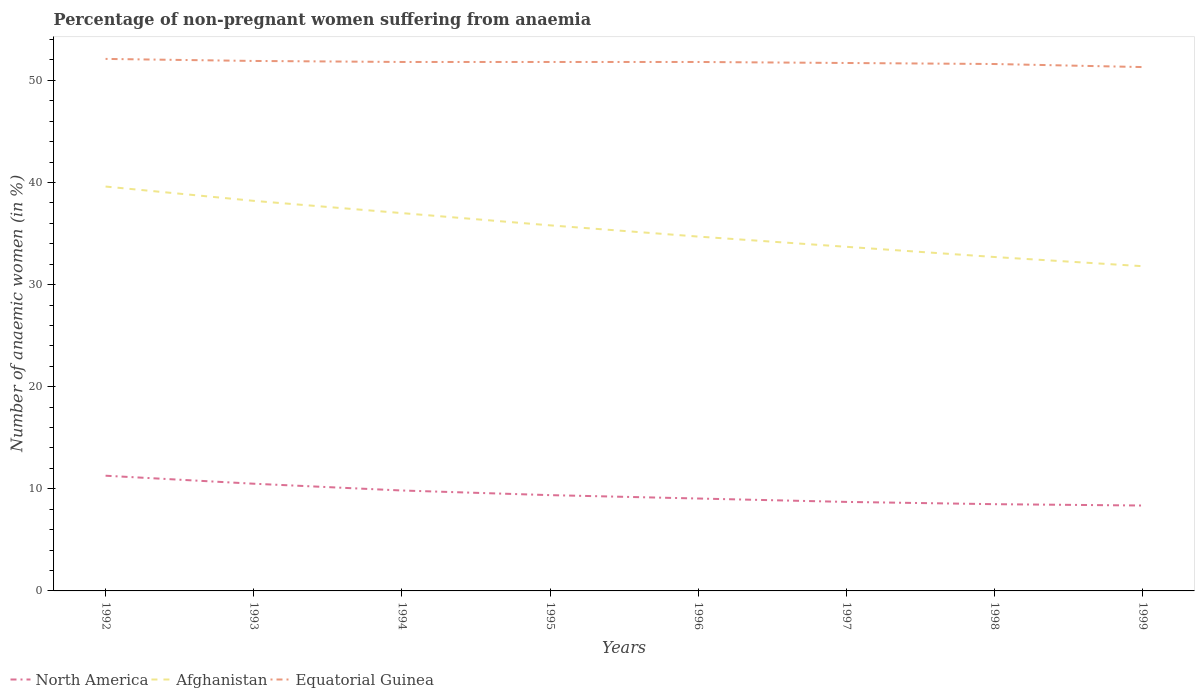Across all years, what is the maximum percentage of non-pregnant women suffering from anaemia in North America?
Give a very brief answer. 8.36. In which year was the percentage of non-pregnant women suffering from anaemia in North America maximum?
Give a very brief answer. 1999. What is the difference between the highest and the second highest percentage of non-pregnant women suffering from anaemia in North America?
Your answer should be very brief. 2.92. Is the percentage of non-pregnant women suffering from anaemia in North America strictly greater than the percentage of non-pregnant women suffering from anaemia in Afghanistan over the years?
Give a very brief answer. Yes. How many years are there in the graph?
Give a very brief answer. 8. Are the values on the major ticks of Y-axis written in scientific E-notation?
Keep it short and to the point. No. Does the graph contain any zero values?
Your answer should be very brief. No. Does the graph contain grids?
Your answer should be compact. No. How many legend labels are there?
Make the answer very short. 3. How are the legend labels stacked?
Ensure brevity in your answer.  Horizontal. What is the title of the graph?
Your answer should be compact. Percentage of non-pregnant women suffering from anaemia. What is the label or title of the X-axis?
Keep it short and to the point. Years. What is the label or title of the Y-axis?
Offer a very short reply. Number of anaemic women (in %). What is the Number of anaemic women (in %) in North America in 1992?
Provide a succinct answer. 11.28. What is the Number of anaemic women (in %) of Afghanistan in 1992?
Keep it short and to the point. 39.6. What is the Number of anaemic women (in %) in Equatorial Guinea in 1992?
Provide a short and direct response. 52.1. What is the Number of anaemic women (in %) of North America in 1993?
Your answer should be very brief. 10.5. What is the Number of anaemic women (in %) in Afghanistan in 1993?
Provide a succinct answer. 38.2. What is the Number of anaemic women (in %) in Equatorial Guinea in 1993?
Provide a succinct answer. 51.9. What is the Number of anaemic women (in %) in North America in 1994?
Offer a very short reply. 9.83. What is the Number of anaemic women (in %) in Equatorial Guinea in 1994?
Your response must be concise. 51.8. What is the Number of anaemic women (in %) in North America in 1995?
Offer a terse response. 9.38. What is the Number of anaemic women (in %) of Afghanistan in 1995?
Offer a very short reply. 35.8. What is the Number of anaemic women (in %) of Equatorial Guinea in 1995?
Offer a terse response. 51.8. What is the Number of anaemic women (in %) of North America in 1996?
Ensure brevity in your answer.  9.05. What is the Number of anaemic women (in %) of Afghanistan in 1996?
Offer a very short reply. 34.7. What is the Number of anaemic women (in %) in Equatorial Guinea in 1996?
Provide a succinct answer. 51.8. What is the Number of anaemic women (in %) in North America in 1997?
Your answer should be very brief. 8.72. What is the Number of anaemic women (in %) in Afghanistan in 1997?
Your answer should be compact. 33.7. What is the Number of anaemic women (in %) of Equatorial Guinea in 1997?
Your response must be concise. 51.7. What is the Number of anaemic women (in %) in North America in 1998?
Your answer should be compact. 8.49. What is the Number of anaemic women (in %) of Afghanistan in 1998?
Your response must be concise. 32.7. What is the Number of anaemic women (in %) of Equatorial Guinea in 1998?
Your answer should be very brief. 51.6. What is the Number of anaemic women (in %) of North America in 1999?
Provide a succinct answer. 8.36. What is the Number of anaemic women (in %) of Afghanistan in 1999?
Ensure brevity in your answer.  31.8. What is the Number of anaemic women (in %) in Equatorial Guinea in 1999?
Offer a terse response. 51.3. Across all years, what is the maximum Number of anaemic women (in %) of North America?
Provide a succinct answer. 11.28. Across all years, what is the maximum Number of anaemic women (in %) in Afghanistan?
Provide a succinct answer. 39.6. Across all years, what is the maximum Number of anaemic women (in %) in Equatorial Guinea?
Provide a succinct answer. 52.1. Across all years, what is the minimum Number of anaemic women (in %) in North America?
Provide a short and direct response. 8.36. Across all years, what is the minimum Number of anaemic women (in %) in Afghanistan?
Ensure brevity in your answer.  31.8. Across all years, what is the minimum Number of anaemic women (in %) of Equatorial Guinea?
Keep it short and to the point. 51.3. What is the total Number of anaemic women (in %) of North America in the graph?
Give a very brief answer. 75.62. What is the total Number of anaemic women (in %) in Afghanistan in the graph?
Offer a very short reply. 283.5. What is the total Number of anaemic women (in %) of Equatorial Guinea in the graph?
Make the answer very short. 414. What is the difference between the Number of anaemic women (in %) in North America in 1992 and that in 1993?
Your answer should be compact. 0.78. What is the difference between the Number of anaemic women (in %) in Afghanistan in 1992 and that in 1993?
Provide a short and direct response. 1.4. What is the difference between the Number of anaemic women (in %) in North America in 1992 and that in 1994?
Ensure brevity in your answer.  1.45. What is the difference between the Number of anaemic women (in %) in Afghanistan in 1992 and that in 1994?
Provide a succinct answer. 2.6. What is the difference between the Number of anaemic women (in %) of Equatorial Guinea in 1992 and that in 1994?
Your answer should be compact. 0.3. What is the difference between the Number of anaemic women (in %) of North America in 1992 and that in 1995?
Ensure brevity in your answer.  1.9. What is the difference between the Number of anaemic women (in %) in Afghanistan in 1992 and that in 1995?
Give a very brief answer. 3.8. What is the difference between the Number of anaemic women (in %) of North America in 1992 and that in 1996?
Your answer should be compact. 2.23. What is the difference between the Number of anaemic women (in %) of Afghanistan in 1992 and that in 1996?
Offer a very short reply. 4.9. What is the difference between the Number of anaemic women (in %) of Equatorial Guinea in 1992 and that in 1996?
Keep it short and to the point. 0.3. What is the difference between the Number of anaemic women (in %) in North America in 1992 and that in 1997?
Give a very brief answer. 2.57. What is the difference between the Number of anaemic women (in %) in Afghanistan in 1992 and that in 1997?
Your response must be concise. 5.9. What is the difference between the Number of anaemic women (in %) of Equatorial Guinea in 1992 and that in 1997?
Your response must be concise. 0.4. What is the difference between the Number of anaemic women (in %) of North America in 1992 and that in 1998?
Offer a very short reply. 2.79. What is the difference between the Number of anaemic women (in %) of Afghanistan in 1992 and that in 1998?
Offer a terse response. 6.9. What is the difference between the Number of anaemic women (in %) of Equatorial Guinea in 1992 and that in 1998?
Keep it short and to the point. 0.5. What is the difference between the Number of anaemic women (in %) in North America in 1992 and that in 1999?
Provide a succinct answer. 2.92. What is the difference between the Number of anaemic women (in %) in North America in 1993 and that in 1994?
Your answer should be compact. 0.66. What is the difference between the Number of anaemic women (in %) in Equatorial Guinea in 1993 and that in 1994?
Offer a terse response. 0.1. What is the difference between the Number of anaemic women (in %) in North America in 1993 and that in 1995?
Keep it short and to the point. 1.12. What is the difference between the Number of anaemic women (in %) in Afghanistan in 1993 and that in 1995?
Keep it short and to the point. 2.4. What is the difference between the Number of anaemic women (in %) of Equatorial Guinea in 1993 and that in 1995?
Give a very brief answer. 0.1. What is the difference between the Number of anaemic women (in %) of North America in 1993 and that in 1996?
Your answer should be compact. 1.45. What is the difference between the Number of anaemic women (in %) of Equatorial Guinea in 1993 and that in 1996?
Make the answer very short. 0.1. What is the difference between the Number of anaemic women (in %) of North America in 1993 and that in 1997?
Your response must be concise. 1.78. What is the difference between the Number of anaemic women (in %) of North America in 1993 and that in 1998?
Provide a succinct answer. 2. What is the difference between the Number of anaemic women (in %) in Afghanistan in 1993 and that in 1998?
Your answer should be very brief. 5.5. What is the difference between the Number of anaemic women (in %) of Equatorial Guinea in 1993 and that in 1998?
Give a very brief answer. 0.3. What is the difference between the Number of anaemic women (in %) in North America in 1993 and that in 1999?
Offer a terse response. 2.14. What is the difference between the Number of anaemic women (in %) of Afghanistan in 1993 and that in 1999?
Give a very brief answer. 6.4. What is the difference between the Number of anaemic women (in %) of Equatorial Guinea in 1993 and that in 1999?
Offer a very short reply. 0.6. What is the difference between the Number of anaemic women (in %) of North America in 1994 and that in 1995?
Your answer should be very brief. 0.45. What is the difference between the Number of anaemic women (in %) of North America in 1994 and that in 1996?
Give a very brief answer. 0.79. What is the difference between the Number of anaemic women (in %) in Afghanistan in 1994 and that in 1996?
Provide a succinct answer. 2.3. What is the difference between the Number of anaemic women (in %) in North America in 1994 and that in 1997?
Ensure brevity in your answer.  1.12. What is the difference between the Number of anaemic women (in %) in Afghanistan in 1994 and that in 1997?
Offer a very short reply. 3.3. What is the difference between the Number of anaemic women (in %) of North America in 1994 and that in 1998?
Provide a short and direct response. 1.34. What is the difference between the Number of anaemic women (in %) of North America in 1994 and that in 1999?
Your response must be concise. 1.47. What is the difference between the Number of anaemic women (in %) of North America in 1995 and that in 1996?
Make the answer very short. 0.33. What is the difference between the Number of anaemic women (in %) of Afghanistan in 1995 and that in 1996?
Offer a terse response. 1.1. What is the difference between the Number of anaemic women (in %) in Equatorial Guinea in 1995 and that in 1996?
Your response must be concise. 0. What is the difference between the Number of anaemic women (in %) of North America in 1995 and that in 1997?
Your answer should be compact. 0.66. What is the difference between the Number of anaemic women (in %) in Afghanistan in 1995 and that in 1997?
Give a very brief answer. 2.1. What is the difference between the Number of anaemic women (in %) in Equatorial Guinea in 1995 and that in 1997?
Offer a terse response. 0.1. What is the difference between the Number of anaemic women (in %) in North America in 1995 and that in 1998?
Offer a terse response. 0.89. What is the difference between the Number of anaemic women (in %) of North America in 1996 and that in 1997?
Make the answer very short. 0.33. What is the difference between the Number of anaemic women (in %) in Afghanistan in 1996 and that in 1997?
Give a very brief answer. 1. What is the difference between the Number of anaemic women (in %) of Equatorial Guinea in 1996 and that in 1997?
Ensure brevity in your answer.  0.1. What is the difference between the Number of anaemic women (in %) of North America in 1996 and that in 1998?
Keep it short and to the point. 0.55. What is the difference between the Number of anaemic women (in %) of Equatorial Guinea in 1996 and that in 1998?
Provide a succinct answer. 0.2. What is the difference between the Number of anaemic women (in %) of North America in 1996 and that in 1999?
Give a very brief answer. 0.69. What is the difference between the Number of anaemic women (in %) of Equatorial Guinea in 1996 and that in 1999?
Your response must be concise. 0.5. What is the difference between the Number of anaemic women (in %) in North America in 1997 and that in 1998?
Ensure brevity in your answer.  0.22. What is the difference between the Number of anaemic women (in %) in Afghanistan in 1997 and that in 1998?
Give a very brief answer. 1. What is the difference between the Number of anaemic women (in %) of North America in 1997 and that in 1999?
Offer a very short reply. 0.35. What is the difference between the Number of anaemic women (in %) in Equatorial Guinea in 1997 and that in 1999?
Make the answer very short. 0.4. What is the difference between the Number of anaemic women (in %) of North America in 1998 and that in 1999?
Offer a very short reply. 0.13. What is the difference between the Number of anaemic women (in %) in North America in 1992 and the Number of anaemic women (in %) in Afghanistan in 1993?
Your answer should be compact. -26.92. What is the difference between the Number of anaemic women (in %) in North America in 1992 and the Number of anaemic women (in %) in Equatorial Guinea in 1993?
Keep it short and to the point. -40.62. What is the difference between the Number of anaemic women (in %) in North America in 1992 and the Number of anaemic women (in %) in Afghanistan in 1994?
Offer a terse response. -25.72. What is the difference between the Number of anaemic women (in %) in North America in 1992 and the Number of anaemic women (in %) in Equatorial Guinea in 1994?
Make the answer very short. -40.52. What is the difference between the Number of anaemic women (in %) of North America in 1992 and the Number of anaemic women (in %) of Afghanistan in 1995?
Offer a very short reply. -24.52. What is the difference between the Number of anaemic women (in %) of North America in 1992 and the Number of anaemic women (in %) of Equatorial Guinea in 1995?
Give a very brief answer. -40.52. What is the difference between the Number of anaemic women (in %) of Afghanistan in 1992 and the Number of anaemic women (in %) of Equatorial Guinea in 1995?
Your response must be concise. -12.2. What is the difference between the Number of anaemic women (in %) of North America in 1992 and the Number of anaemic women (in %) of Afghanistan in 1996?
Your answer should be very brief. -23.42. What is the difference between the Number of anaemic women (in %) in North America in 1992 and the Number of anaemic women (in %) in Equatorial Guinea in 1996?
Keep it short and to the point. -40.52. What is the difference between the Number of anaemic women (in %) of North America in 1992 and the Number of anaemic women (in %) of Afghanistan in 1997?
Make the answer very short. -22.42. What is the difference between the Number of anaemic women (in %) in North America in 1992 and the Number of anaemic women (in %) in Equatorial Guinea in 1997?
Offer a very short reply. -40.42. What is the difference between the Number of anaemic women (in %) of North America in 1992 and the Number of anaemic women (in %) of Afghanistan in 1998?
Keep it short and to the point. -21.42. What is the difference between the Number of anaemic women (in %) in North America in 1992 and the Number of anaemic women (in %) in Equatorial Guinea in 1998?
Make the answer very short. -40.32. What is the difference between the Number of anaemic women (in %) of Afghanistan in 1992 and the Number of anaemic women (in %) of Equatorial Guinea in 1998?
Your answer should be compact. -12. What is the difference between the Number of anaemic women (in %) in North America in 1992 and the Number of anaemic women (in %) in Afghanistan in 1999?
Your answer should be compact. -20.52. What is the difference between the Number of anaemic women (in %) in North America in 1992 and the Number of anaemic women (in %) in Equatorial Guinea in 1999?
Offer a very short reply. -40.02. What is the difference between the Number of anaemic women (in %) of North America in 1993 and the Number of anaemic women (in %) of Afghanistan in 1994?
Keep it short and to the point. -26.5. What is the difference between the Number of anaemic women (in %) of North America in 1993 and the Number of anaemic women (in %) of Equatorial Guinea in 1994?
Provide a short and direct response. -41.3. What is the difference between the Number of anaemic women (in %) in Afghanistan in 1993 and the Number of anaemic women (in %) in Equatorial Guinea in 1994?
Ensure brevity in your answer.  -13.6. What is the difference between the Number of anaemic women (in %) in North America in 1993 and the Number of anaemic women (in %) in Afghanistan in 1995?
Your response must be concise. -25.3. What is the difference between the Number of anaemic women (in %) of North America in 1993 and the Number of anaemic women (in %) of Equatorial Guinea in 1995?
Give a very brief answer. -41.3. What is the difference between the Number of anaemic women (in %) of North America in 1993 and the Number of anaemic women (in %) of Afghanistan in 1996?
Your response must be concise. -24.2. What is the difference between the Number of anaemic women (in %) in North America in 1993 and the Number of anaemic women (in %) in Equatorial Guinea in 1996?
Your response must be concise. -41.3. What is the difference between the Number of anaemic women (in %) in Afghanistan in 1993 and the Number of anaemic women (in %) in Equatorial Guinea in 1996?
Give a very brief answer. -13.6. What is the difference between the Number of anaemic women (in %) of North America in 1993 and the Number of anaemic women (in %) of Afghanistan in 1997?
Your answer should be very brief. -23.2. What is the difference between the Number of anaemic women (in %) of North America in 1993 and the Number of anaemic women (in %) of Equatorial Guinea in 1997?
Provide a short and direct response. -41.2. What is the difference between the Number of anaemic women (in %) in North America in 1993 and the Number of anaemic women (in %) in Afghanistan in 1998?
Your response must be concise. -22.2. What is the difference between the Number of anaemic women (in %) of North America in 1993 and the Number of anaemic women (in %) of Equatorial Guinea in 1998?
Keep it short and to the point. -41.1. What is the difference between the Number of anaemic women (in %) in Afghanistan in 1993 and the Number of anaemic women (in %) in Equatorial Guinea in 1998?
Your answer should be compact. -13.4. What is the difference between the Number of anaemic women (in %) in North America in 1993 and the Number of anaemic women (in %) in Afghanistan in 1999?
Your answer should be compact. -21.3. What is the difference between the Number of anaemic women (in %) in North America in 1993 and the Number of anaemic women (in %) in Equatorial Guinea in 1999?
Give a very brief answer. -40.8. What is the difference between the Number of anaemic women (in %) in North America in 1994 and the Number of anaemic women (in %) in Afghanistan in 1995?
Give a very brief answer. -25.97. What is the difference between the Number of anaemic women (in %) in North America in 1994 and the Number of anaemic women (in %) in Equatorial Guinea in 1995?
Offer a terse response. -41.97. What is the difference between the Number of anaemic women (in %) of Afghanistan in 1994 and the Number of anaemic women (in %) of Equatorial Guinea in 1995?
Keep it short and to the point. -14.8. What is the difference between the Number of anaemic women (in %) of North America in 1994 and the Number of anaemic women (in %) of Afghanistan in 1996?
Ensure brevity in your answer.  -24.87. What is the difference between the Number of anaemic women (in %) in North America in 1994 and the Number of anaemic women (in %) in Equatorial Guinea in 1996?
Keep it short and to the point. -41.97. What is the difference between the Number of anaemic women (in %) of Afghanistan in 1994 and the Number of anaemic women (in %) of Equatorial Guinea in 1996?
Keep it short and to the point. -14.8. What is the difference between the Number of anaemic women (in %) of North America in 1994 and the Number of anaemic women (in %) of Afghanistan in 1997?
Ensure brevity in your answer.  -23.87. What is the difference between the Number of anaemic women (in %) in North America in 1994 and the Number of anaemic women (in %) in Equatorial Guinea in 1997?
Provide a short and direct response. -41.87. What is the difference between the Number of anaemic women (in %) of Afghanistan in 1994 and the Number of anaemic women (in %) of Equatorial Guinea in 1997?
Provide a short and direct response. -14.7. What is the difference between the Number of anaemic women (in %) in North America in 1994 and the Number of anaemic women (in %) in Afghanistan in 1998?
Ensure brevity in your answer.  -22.87. What is the difference between the Number of anaemic women (in %) of North America in 1994 and the Number of anaemic women (in %) of Equatorial Guinea in 1998?
Keep it short and to the point. -41.77. What is the difference between the Number of anaemic women (in %) in Afghanistan in 1994 and the Number of anaemic women (in %) in Equatorial Guinea in 1998?
Your answer should be compact. -14.6. What is the difference between the Number of anaemic women (in %) in North America in 1994 and the Number of anaemic women (in %) in Afghanistan in 1999?
Make the answer very short. -21.97. What is the difference between the Number of anaemic women (in %) in North America in 1994 and the Number of anaemic women (in %) in Equatorial Guinea in 1999?
Ensure brevity in your answer.  -41.47. What is the difference between the Number of anaemic women (in %) of Afghanistan in 1994 and the Number of anaemic women (in %) of Equatorial Guinea in 1999?
Your answer should be very brief. -14.3. What is the difference between the Number of anaemic women (in %) of North America in 1995 and the Number of anaemic women (in %) of Afghanistan in 1996?
Keep it short and to the point. -25.32. What is the difference between the Number of anaemic women (in %) of North America in 1995 and the Number of anaemic women (in %) of Equatorial Guinea in 1996?
Offer a very short reply. -42.42. What is the difference between the Number of anaemic women (in %) in North America in 1995 and the Number of anaemic women (in %) in Afghanistan in 1997?
Offer a very short reply. -24.32. What is the difference between the Number of anaemic women (in %) of North America in 1995 and the Number of anaemic women (in %) of Equatorial Guinea in 1997?
Keep it short and to the point. -42.32. What is the difference between the Number of anaemic women (in %) of Afghanistan in 1995 and the Number of anaemic women (in %) of Equatorial Guinea in 1997?
Your answer should be compact. -15.9. What is the difference between the Number of anaemic women (in %) of North America in 1995 and the Number of anaemic women (in %) of Afghanistan in 1998?
Offer a terse response. -23.32. What is the difference between the Number of anaemic women (in %) in North America in 1995 and the Number of anaemic women (in %) in Equatorial Guinea in 1998?
Ensure brevity in your answer.  -42.22. What is the difference between the Number of anaemic women (in %) in Afghanistan in 1995 and the Number of anaemic women (in %) in Equatorial Guinea in 1998?
Give a very brief answer. -15.8. What is the difference between the Number of anaemic women (in %) in North America in 1995 and the Number of anaemic women (in %) in Afghanistan in 1999?
Offer a very short reply. -22.42. What is the difference between the Number of anaemic women (in %) of North America in 1995 and the Number of anaemic women (in %) of Equatorial Guinea in 1999?
Give a very brief answer. -41.92. What is the difference between the Number of anaemic women (in %) in Afghanistan in 1995 and the Number of anaemic women (in %) in Equatorial Guinea in 1999?
Provide a short and direct response. -15.5. What is the difference between the Number of anaemic women (in %) of North America in 1996 and the Number of anaemic women (in %) of Afghanistan in 1997?
Your answer should be very brief. -24.65. What is the difference between the Number of anaemic women (in %) in North America in 1996 and the Number of anaemic women (in %) in Equatorial Guinea in 1997?
Provide a short and direct response. -42.65. What is the difference between the Number of anaemic women (in %) in North America in 1996 and the Number of anaemic women (in %) in Afghanistan in 1998?
Ensure brevity in your answer.  -23.65. What is the difference between the Number of anaemic women (in %) in North America in 1996 and the Number of anaemic women (in %) in Equatorial Guinea in 1998?
Provide a short and direct response. -42.55. What is the difference between the Number of anaemic women (in %) of Afghanistan in 1996 and the Number of anaemic women (in %) of Equatorial Guinea in 1998?
Make the answer very short. -16.9. What is the difference between the Number of anaemic women (in %) of North America in 1996 and the Number of anaemic women (in %) of Afghanistan in 1999?
Your response must be concise. -22.75. What is the difference between the Number of anaemic women (in %) in North America in 1996 and the Number of anaemic women (in %) in Equatorial Guinea in 1999?
Give a very brief answer. -42.25. What is the difference between the Number of anaemic women (in %) in Afghanistan in 1996 and the Number of anaemic women (in %) in Equatorial Guinea in 1999?
Your answer should be very brief. -16.6. What is the difference between the Number of anaemic women (in %) of North America in 1997 and the Number of anaemic women (in %) of Afghanistan in 1998?
Ensure brevity in your answer.  -23.98. What is the difference between the Number of anaemic women (in %) in North America in 1997 and the Number of anaemic women (in %) in Equatorial Guinea in 1998?
Offer a terse response. -42.88. What is the difference between the Number of anaemic women (in %) of Afghanistan in 1997 and the Number of anaemic women (in %) of Equatorial Guinea in 1998?
Your answer should be compact. -17.9. What is the difference between the Number of anaemic women (in %) of North America in 1997 and the Number of anaemic women (in %) of Afghanistan in 1999?
Make the answer very short. -23.08. What is the difference between the Number of anaemic women (in %) of North America in 1997 and the Number of anaemic women (in %) of Equatorial Guinea in 1999?
Offer a very short reply. -42.58. What is the difference between the Number of anaemic women (in %) of Afghanistan in 1997 and the Number of anaemic women (in %) of Equatorial Guinea in 1999?
Give a very brief answer. -17.6. What is the difference between the Number of anaemic women (in %) in North America in 1998 and the Number of anaemic women (in %) in Afghanistan in 1999?
Make the answer very short. -23.31. What is the difference between the Number of anaemic women (in %) in North America in 1998 and the Number of anaemic women (in %) in Equatorial Guinea in 1999?
Offer a terse response. -42.81. What is the difference between the Number of anaemic women (in %) of Afghanistan in 1998 and the Number of anaemic women (in %) of Equatorial Guinea in 1999?
Provide a succinct answer. -18.6. What is the average Number of anaemic women (in %) of North America per year?
Make the answer very short. 9.45. What is the average Number of anaemic women (in %) in Afghanistan per year?
Give a very brief answer. 35.44. What is the average Number of anaemic women (in %) of Equatorial Guinea per year?
Offer a very short reply. 51.75. In the year 1992, what is the difference between the Number of anaemic women (in %) of North America and Number of anaemic women (in %) of Afghanistan?
Provide a succinct answer. -28.32. In the year 1992, what is the difference between the Number of anaemic women (in %) of North America and Number of anaemic women (in %) of Equatorial Guinea?
Your answer should be very brief. -40.82. In the year 1992, what is the difference between the Number of anaemic women (in %) of Afghanistan and Number of anaemic women (in %) of Equatorial Guinea?
Offer a very short reply. -12.5. In the year 1993, what is the difference between the Number of anaemic women (in %) of North America and Number of anaemic women (in %) of Afghanistan?
Your response must be concise. -27.7. In the year 1993, what is the difference between the Number of anaemic women (in %) of North America and Number of anaemic women (in %) of Equatorial Guinea?
Give a very brief answer. -41.4. In the year 1993, what is the difference between the Number of anaemic women (in %) in Afghanistan and Number of anaemic women (in %) in Equatorial Guinea?
Provide a succinct answer. -13.7. In the year 1994, what is the difference between the Number of anaemic women (in %) in North America and Number of anaemic women (in %) in Afghanistan?
Provide a short and direct response. -27.17. In the year 1994, what is the difference between the Number of anaemic women (in %) in North America and Number of anaemic women (in %) in Equatorial Guinea?
Ensure brevity in your answer.  -41.97. In the year 1994, what is the difference between the Number of anaemic women (in %) of Afghanistan and Number of anaemic women (in %) of Equatorial Guinea?
Your answer should be very brief. -14.8. In the year 1995, what is the difference between the Number of anaemic women (in %) in North America and Number of anaemic women (in %) in Afghanistan?
Provide a short and direct response. -26.42. In the year 1995, what is the difference between the Number of anaemic women (in %) in North America and Number of anaemic women (in %) in Equatorial Guinea?
Keep it short and to the point. -42.42. In the year 1995, what is the difference between the Number of anaemic women (in %) of Afghanistan and Number of anaemic women (in %) of Equatorial Guinea?
Give a very brief answer. -16. In the year 1996, what is the difference between the Number of anaemic women (in %) in North America and Number of anaemic women (in %) in Afghanistan?
Your response must be concise. -25.65. In the year 1996, what is the difference between the Number of anaemic women (in %) in North America and Number of anaemic women (in %) in Equatorial Guinea?
Offer a very short reply. -42.75. In the year 1996, what is the difference between the Number of anaemic women (in %) of Afghanistan and Number of anaemic women (in %) of Equatorial Guinea?
Keep it short and to the point. -17.1. In the year 1997, what is the difference between the Number of anaemic women (in %) in North America and Number of anaemic women (in %) in Afghanistan?
Your answer should be compact. -24.98. In the year 1997, what is the difference between the Number of anaemic women (in %) in North America and Number of anaemic women (in %) in Equatorial Guinea?
Make the answer very short. -42.98. In the year 1997, what is the difference between the Number of anaemic women (in %) of Afghanistan and Number of anaemic women (in %) of Equatorial Guinea?
Provide a short and direct response. -18. In the year 1998, what is the difference between the Number of anaemic women (in %) in North America and Number of anaemic women (in %) in Afghanistan?
Give a very brief answer. -24.21. In the year 1998, what is the difference between the Number of anaemic women (in %) of North America and Number of anaemic women (in %) of Equatorial Guinea?
Offer a terse response. -43.11. In the year 1998, what is the difference between the Number of anaemic women (in %) of Afghanistan and Number of anaemic women (in %) of Equatorial Guinea?
Make the answer very short. -18.9. In the year 1999, what is the difference between the Number of anaemic women (in %) in North America and Number of anaemic women (in %) in Afghanistan?
Give a very brief answer. -23.44. In the year 1999, what is the difference between the Number of anaemic women (in %) of North America and Number of anaemic women (in %) of Equatorial Guinea?
Offer a terse response. -42.94. In the year 1999, what is the difference between the Number of anaemic women (in %) in Afghanistan and Number of anaemic women (in %) in Equatorial Guinea?
Your response must be concise. -19.5. What is the ratio of the Number of anaemic women (in %) in North America in 1992 to that in 1993?
Make the answer very short. 1.07. What is the ratio of the Number of anaemic women (in %) of Afghanistan in 1992 to that in 1993?
Ensure brevity in your answer.  1.04. What is the ratio of the Number of anaemic women (in %) in North America in 1992 to that in 1994?
Offer a terse response. 1.15. What is the ratio of the Number of anaemic women (in %) in Afghanistan in 1992 to that in 1994?
Give a very brief answer. 1.07. What is the ratio of the Number of anaemic women (in %) of North America in 1992 to that in 1995?
Keep it short and to the point. 1.2. What is the ratio of the Number of anaemic women (in %) of Afghanistan in 1992 to that in 1995?
Your answer should be very brief. 1.11. What is the ratio of the Number of anaemic women (in %) in North America in 1992 to that in 1996?
Keep it short and to the point. 1.25. What is the ratio of the Number of anaemic women (in %) of Afghanistan in 1992 to that in 1996?
Offer a very short reply. 1.14. What is the ratio of the Number of anaemic women (in %) in Equatorial Guinea in 1992 to that in 1996?
Your answer should be very brief. 1.01. What is the ratio of the Number of anaemic women (in %) in North America in 1992 to that in 1997?
Ensure brevity in your answer.  1.29. What is the ratio of the Number of anaemic women (in %) in Afghanistan in 1992 to that in 1997?
Your answer should be very brief. 1.18. What is the ratio of the Number of anaemic women (in %) in Equatorial Guinea in 1992 to that in 1997?
Offer a very short reply. 1.01. What is the ratio of the Number of anaemic women (in %) of North America in 1992 to that in 1998?
Your answer should be very brief. 1.33. What is the ratio of the Number of anaemic women (in %) of Afghanistan in 1992 to that in 1998?
Ensure brevity in your answer.  1.21. What is the ratio of the Number of anaemic women (in %) of Equatorial Guinea in 1992 to that in 1998?
Ensure brevity in your answer.  1.01. What is the ratio of the Number of anaemic women (in %) in North America in 1992 to that in 1999?
Ensure brevity in your answer.  1.35. What is the ratio of the Number of anaemic women (in %) in Afghanistan in 1992 to that in 1999?
Provide a short and direct response. 1.25. What is the ratio of the Number of anaemic women (in %) of Equatorial Guinea in 1992 to that in 1999?
Your response must be concise. 1.02. What is the ratio of the Number of anaemic women (in %) in North America in 1993 to that in 1994?
Your answer should be very brief. 1.07. What is the ratio of the Number of anaemic women (in %) of Afghanistan in 1993 to that in 1994?
Give a very brief answer. 1.03. What is the ratio of the Number of anaemic women (in %) in North America in 1993 to that in 1995?
Ensure brevity in your answer.  1.12. What is the ratio of the Number of anaemic women (in %) of Afghanistan in 1993 to that in 1995?
Provide a short and direct response. 1.07. What is the ratio of the Number of anaemic women (in %) in Equatorial Guinea in 1993 to that in 1995?
Keep it short and to the point. 1. What is the ratio of the Number of anaemic women (in %) in North America in 1993 to that in 1996?
Your answer should be compact. 1.16. What is the ratio of the Number of anaemic women (in %) of Afghanistan in 1993 to that in 1996?
Offer a very short reply. 1.1. What is the ratio of the Number of anaemic women (in %) of Equatorial Guinea in 1993 to that in 1996?
Give a very brief answer. 1. What is the ratio of the Number of anaemic women (in %) of North America in 1993 to that in 1997?
Your answer should be very brief. 1.2. What is the ratio of the Number of anaemic women (in %) of Afghanistan in 1993 to that in 1997?
Ensure brevity in your answer.  1.13. What is the ratio of the Number of anaemic women (in %) of North America in 1993 to that in 1998?
Ensure brevity in your answer.  1.24. What is the ratio of the Number of anaemic women (in %) of Afghanistan in 1993 to that in 1998?
Your answer should be very brief. 1.17. What is the ratio of the Number of anaemic women (in %) of North America in 1993 to that in 1999?
Offer a very short reply. 1.26. What is the ratio of the Number of anaemic women (in %) of Afghanistan in 1993 to that in 1999?
Offer a very short reply. 1.2. What is the ratio of the Number of anaemic women (in %) of Equatorial Guinea in 1993 to that in 1999?
Make the answer very short. 1.01. What is the ratio of the Number of anaemic women (in %) in North America in 1994 to that in 1995?
Your answer should be compact. 1.05. What is the ratio of the Number of anaemic women (in %) in Afghanistan in 1994 to that in 1995?
Your answer should be compact. 1.03. What is the ratio of the Number of anaemic women (in %) in Equatorial Guinea in 1994 to that in 1995?
Provide a short and direct response. 1. What is the ratio of the Number of anaemic women (in %) of North America in 1994 to that in 1996?
Give a very brief answer. 1.09. What is the ratio of the Number of anaemic women (in %) of Afghanistan in 1994 to that in 1996?
Give a very brief answer. 1.07. What is the ratio of the Number of anaemic women (in %) of Equatorial Guinea in 1994 to that in 1996?
Your response must be concise. 1. What is the ratio of the Number of anaemic women (in %) in North America in 1994 to that in 1997?
Your answer should be compact. 1.13. What is the ratio of the Number of anaemic women (in %) of Afghanistan in 1994 to that in 1997?
Make the answer very short. 1.1. What is the ratio of the Number of anaemic women (in %) in Equatorial Guinea in 1994 to that in 1997?
Offer a terse response. 1. What is the ratio of the Number of anaemic women (in %) in North America in 1994 to that in 1998?
Ensure brevity in your answer.  1.16. What is the ratio of the Number of anaemic women (in %) in Afghanistan in 1994 to that in 1998?
Your answer should be very brief. 1.13. What is the ratio of the Number of anaemic women (in %) in Equatorial Guinea in 1994 to that in 1998?
Ensure brevity in your answer.  1. What is the ratio of the Number of anaemic women (in %) in North America in 1994 to that in 1999?
Give a very brief answer. 1.18. What is the ratio of the Number of anaemic women (in %) in Afghanistan in 1994 to that in 1999?
Make the answer very short. 1.16. What is the ratio of the Number of anaemic women (in %) in Equatorial Guinea in 1994 to that in 1999?
Offer a very short reply. 1.01. What is the ratio of the Number of anaemic women (in %) in North America in 1995 to that in 1996?
Ensure brevity in your answer.  1.04. What is the ratio of the Number of anaemic women (in %) in Afghanistan in 1995 to that in 1996?
Offer a terse response. 1.03. What is the ratio of the Number of anaemic women (in %) of North America in 1995 to that in 1997?
Give a very brief answer. 1.08. What is the ratio of the Number of anaemic women (in %) of Afghanistan in 1995 to that in 1997?
Make the answer very short. 1.06. What is the ratio of the Number of anaemic women (in %) in Equatorial Guinea in 1995 to that in 1997?
Offer a terse response. 1. What is the ratio of the Number of anaemic women (in %) in North America in 1995 to that in 1998?
Your answer should be very brief. 1.1. What is the ratio of the Number of anaemic women (in %) in Afghanistan in 1995 to that in 1998?
Offer a very short reply. 1.09. What is the ratio of the Number of anaemic women (in %) in North America in 1995 to that in 1999?
Make the answer very short. 1.12. What is the ratio of the Number of anaemic women (in %) in Afghanistan in 1995 to that in 1999?
Your answer should be compact. 1.13. What is the ratio of the Number of anaemic women (in %) of Equatorial Guinea in 1995 to that in 1999?
Your response must be concise. 1.01. What is the ratio of the Number of anaemic women (in %) of North America in 1996 to that in 1997?
Give a very brief answer. 1.04. What is the ratio of the Number of anaemic women (in %) in Afghanistan in 1996 to that in 1997?
Provide a short and direct response. 1.03. What is the ratio of the Number of anaemic women (in %) of Equatorial Guinea in 1996 to that in 1997?
Your answer should be very brief. 1. What is the ratio of the Number of anaemic women (in %) of North America in 1996 to that in 1998?
Make the answer very short. 1.07. What is the ratio of the Number of anaemic women (in %) of Afghanistan in 1996 to that in 1998?
Keep it short and to the point. 1.06. What is the ratio of the Number of anaemic women (in %) of Equatorial Guinea in 1996 to that in 1998?
Your response must be concise. 1. What is the ratio of the Number of anaemic women (in %) of North America in 1996 to that in 1999?
Ensure brevity in your answer.  1.08. What is the ratio of the Number of anaemic women (in %) of Afghanistan in 1996 to that in 1999?
Your response must be concise. 1.09. What is the ratio of the Number of anaemic women (in %) in Equatorial Guinea in 1996 to that in 1999?
Give a very brief answer. 1.01. What is the ratio of the Number of anaemic women (in %) in North America in 1997 to that in 1998?
Make the answer very short. 1.03. What is the ratio of the Number of anaemic women (in %) of Afghanistan in 1997 to that in 1998?
Your response must be concise. 1.03. What is the ratio of the Number of anaemic women (in %) in North America in 1997 to that in 1999?
Offer a terse response. 1.04. What is the ratio of the Number of anaemic women (in %) of Afghanistan in 1997 to that in 1999?
Give a very brief answer. 1.06. What is the ratio of the Number of anaemic women (in %) of North America in 1998 to that in 1999?
Ensure brevity in your answer.  1.02. What is the ratio of the Number of anaemic women (in %) of Afghanistan in 1998 to that in 1999?
Keep it short and to the point. 1.03. What is the ratio of the Number of anaemic women (in %) of Equatorial Guinea in 1998 to that in 1999?
Provide a succinct answer. 1.01. What is the difference between the highest and the second highest Number of anaemic women (in %) of North America?
Your answer should be compact. 0.78. What is the difference between the highest and the second highest Number of anaemic women (in %) in Afghanistan?
Your answer should be compact. 1.4. What is the difference between the highest and the lowest Number of anaemic women (in %) in North America?
Offer a terse response. 2.92. 